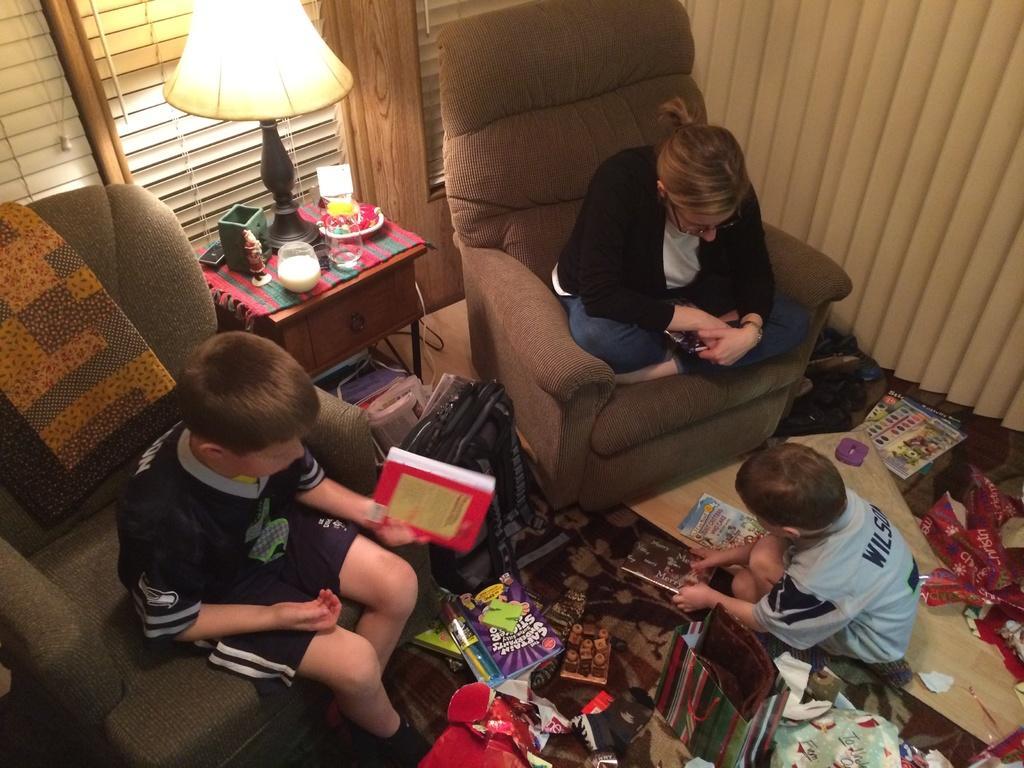Please provide a concise description of this image. One boy wearing a black dress is sitting on a sofa and holding a book. Near to him another lady is sitting on a sofa wearing spectacles. On the floor there is another boy. And there is a table. On the table, there is a mat, glass box and a table lamp. Behind that there is a curtain and a window. On the floor there are books, bag, cover, wrappers and many other items are over there. 